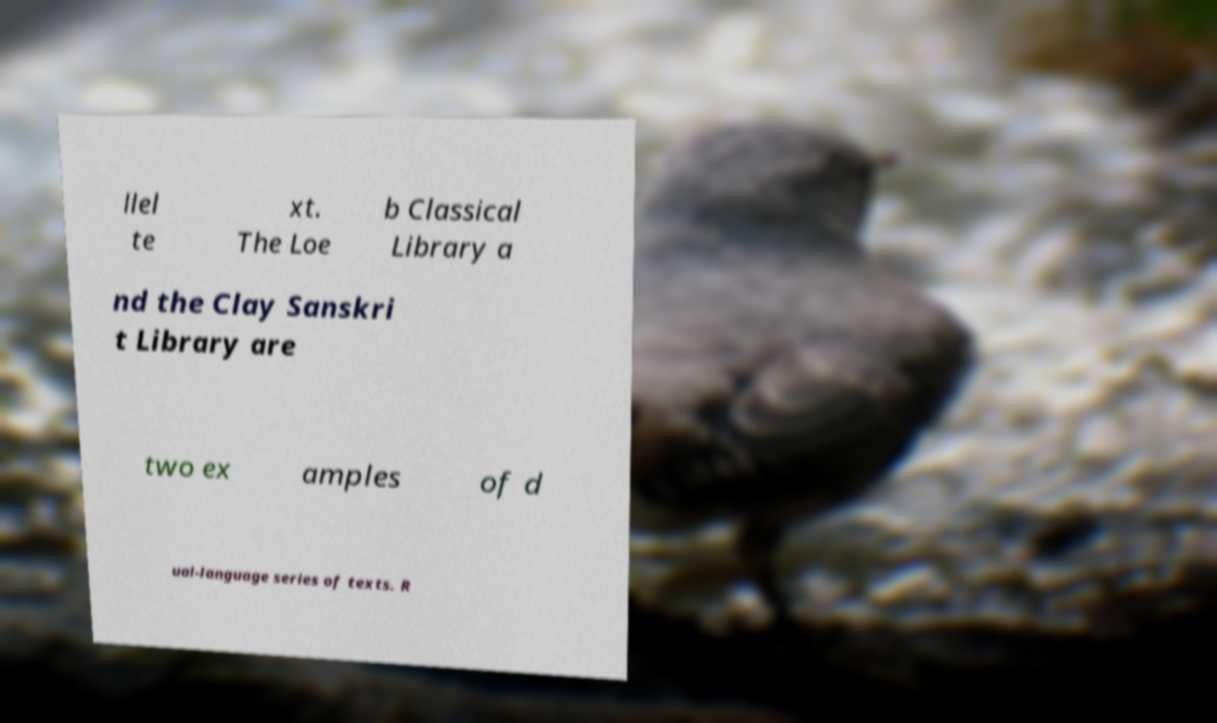Please read and relay the text visible in this image. What does it say? llel te xt. The Loe b Classical Library a nd the Clay Sanskri t Library are two ex amples of d ual-language series of texts. R 